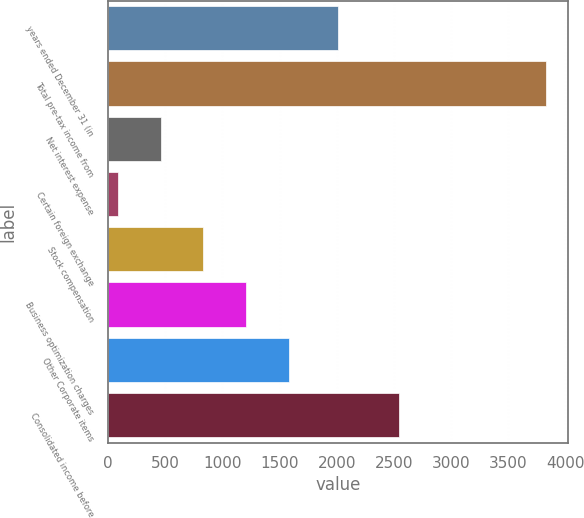Convert chart to OTSL. <chart><loc_0><loc_0><loc_500><loc_500><bar_chart><fcel>years ended December 31 (in<fcel>Total pre-tax income from<fcel>Net interest expense<fcel>Certain foreign exchange<fcel>Stock compensation<fcel>Business optimization charges<fcel>Other Corporate items<fcel>Consolidated income before<nl><fcel>2013<fcel>3833<fcel>458<fcel>83<fcel>833<fcel>1208<fcel>1583<fcel>2549<nl></chart> 